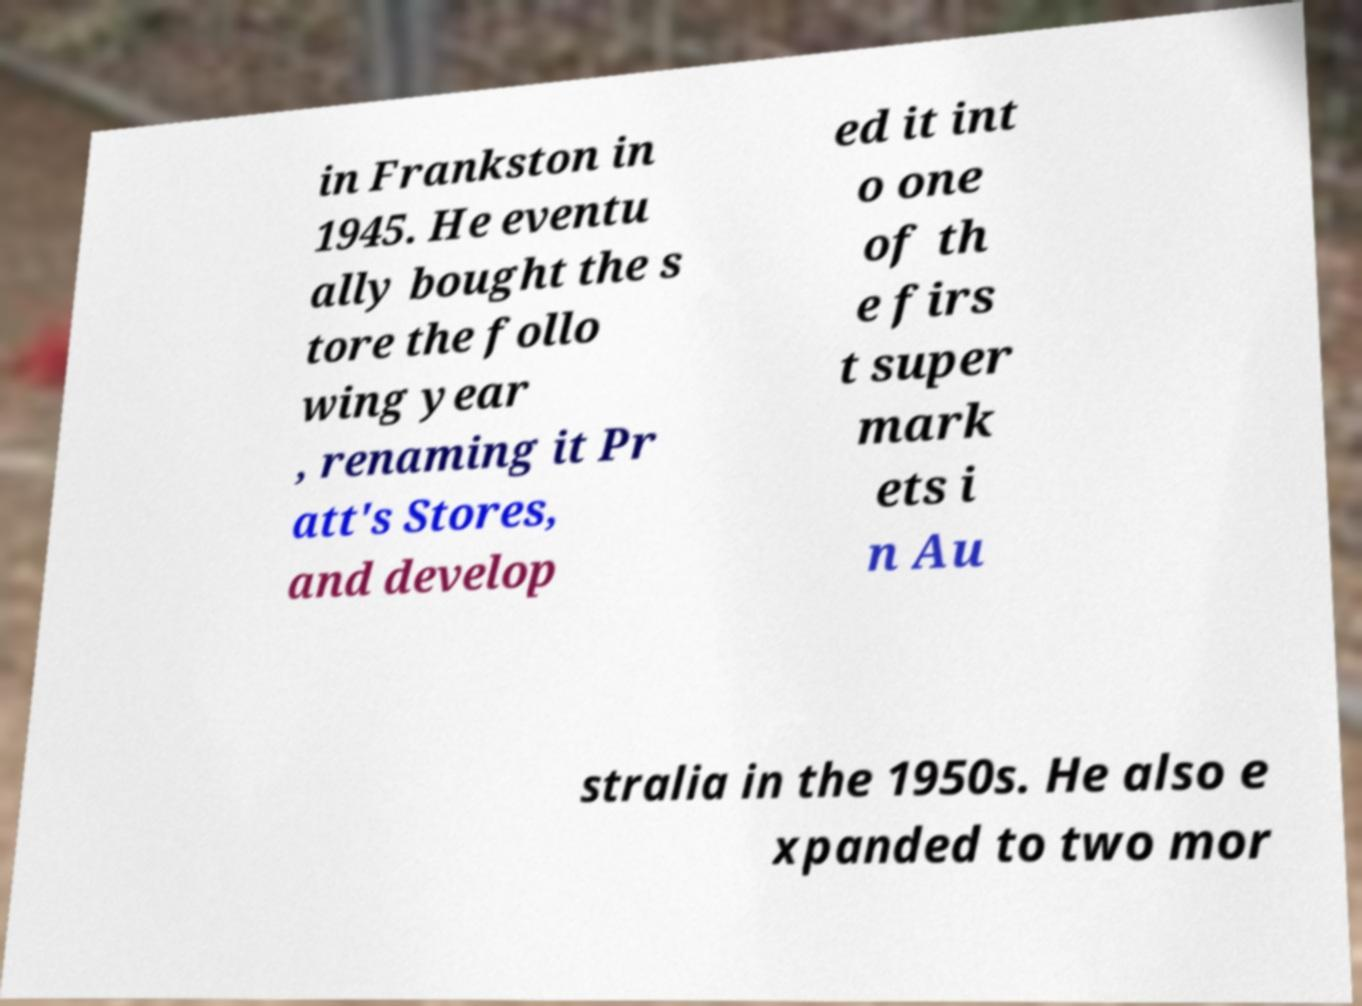Could you assist in decoding the text presented in this image and type it out clearly? in Frankston in 1945. He eventu ally bought the s tore the follo wing year , renaming it Pr att's Stores, and develop ed it int o one of th e firs t super mark ets i n Au stralia in the 1950s. He also e xpanded to two mor 